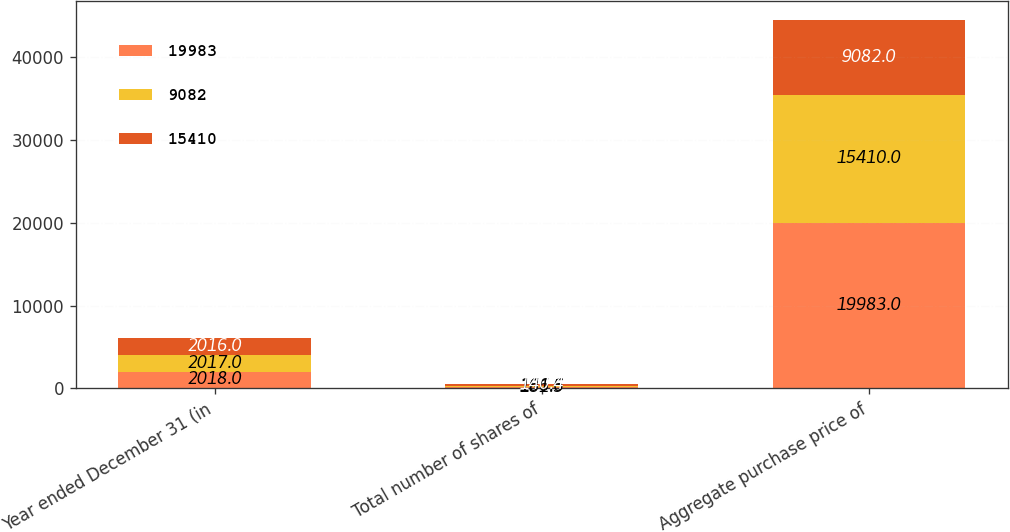Convert chart to OTSL. <chart><loc_0><loc_0><loc_500><loc_500><stacked_bar_chart><ecel><fcel>Year ended December 31 (in<fcel>Total number of shares of<fcel>Aggregate purchase price of<nl><fcel>19983<fcel>2018<fcel>181.5<fcel>19983<nl><fcel>9082<fcel>2017<fcel>166.6<fcel>15410<nl><fcel>15410<fcel>2016<fcel>140.4<fcel>9082<nl></chart> 